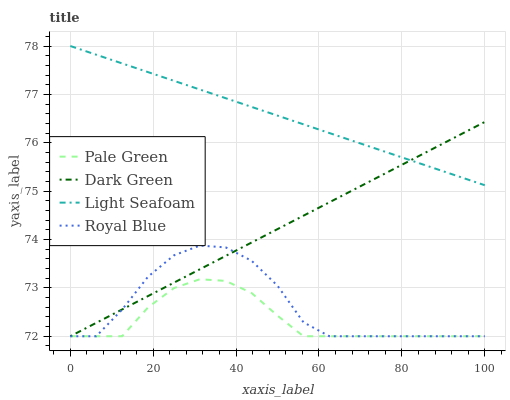Does Pale Green have the minimum area under the curve?
Answer yes or no. Yes. Does Light Seafoam have the maximum area under the curve?
Answer yes or no. Yes. Does Light Seafoam have the minimum area under the curve?
Answer yes or no. No. Does Pale Green have the maximum area under the curve?
Answer yes or no. No. Is Dark Green the smoothest?
Answer yes or no. Yes. Is Royal Blue the roughest?
Answer yes or no. Yes. Is Pale Green the smoothest?
Answer yes or no. No. Is Pale Green the roughest?
Answer yes or no. No. Does Royal Blue have the lowest value?
Answer yes or no. Yes. Does Light Seafoam have the lowest value?
Answer yes or no. No. Does Light Seafoam have the highest value?
Answer yes or no. Yes. Does Pale Green have the highest value?
Answer yes or no. No. Is Royal Blue less than Light Seafoam?
Answer yes or no. Yes. Is Light Seafoam greater than Royal Blue?
Answer yes or no. Yes. Does Light Seafoam intersect Dark Green?
Answer yes or no. Yes. Is Light Seafoam less than Dark Green?
Answer yes or no. No. Is Light Seafoam greater than Dark Green?
Answer yes or no. No. Does Royal Blue intersect Light Seafoam?
Answer yes or no. No. 